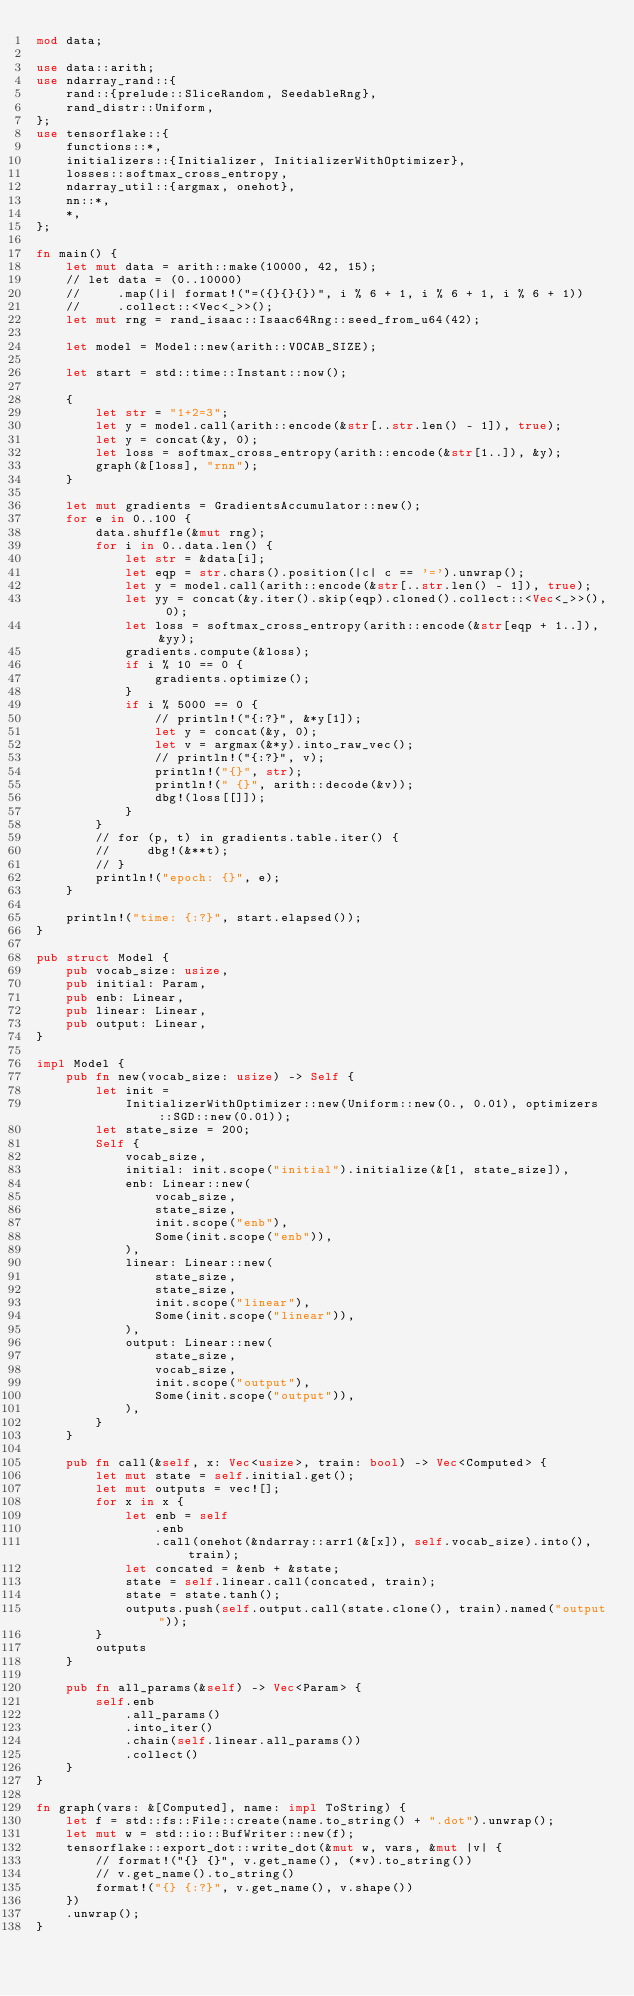<code> <loc_0><loc_0><loc_500><loc_500><_Rust_>mod data;

use data::arith;
use ndarray_rand::{
    rand::{prelude::SliceRandom, SeedableRng},
    rand_distr::Uniform,
};
use tensorflake::{
    functions::*,
    initializers::{Initializer, InitializerWithOptimizer},
    losses::softmax_cross_entropy,
    ndarray_util::{argmax, onehot},
    nn::*,
    *,
};

fn main() {
    let mut data = arith::make(10000, 42, 15);
    // let data = (0..10000)
    //     .map(|i| format!("=({}{}{})", i % 6 + 1, i % 6 + 1, i % 6 + 1))
    //     .collect::<Vec<_>>();
    let mut rng = rand_isaac::Isaac64Rng::seed_from_u64(42);

    let model = Model::new(arith::VOCAB_SIZE);

    let start = std::time::Instant::now();

    {
        let str = "1+2=3";
        let y = model.call(arith::encode(&str[..str.len() - 1]), true);
        let y = concat(&y, 0);
        let loss = softmax_cross_entropy(arith::encode(&str[1..]), &y);
        graph(&[loss], "rnn");
    }

    let mut gradients = GradientsAccumulator::new();
    for e in 0..100 {
        data.shuffle(&mut rng);
        for i in 0..data.len() {
            let str = &data[i];
            let eqp = str.chars().position(|c| c == '=').unwrap();
            let y = model.call(arith::encode(&str[..str.len() - 1]), true);
            let yy = concat(&y.iter().skip(eqp).cloned().collect::<Vec<_>>(), 0);
            let loss = softmax_cross_entropy(arith::encode(&str[eqp + 1..]), &yy);
            gradients.compute(&loss);
            if i % 10 == 0 {
                gradients.optimize();
            }
            if i % 5000 == 0 {
                // println!("{:?}", &*y[1]);
                let y = concat(&y, 0);
                let v = argmax(&*y).into_raw_vec();
                // println!("{:?}", v);
                println!("{}", str);
                println!(" {}", arith::decode(&v));
                dbg!(loss[[]]);
            }
        }
        // for (p, t) in gradients.table.iter() {
        //     dbg!(&**t);
        // }
        println!("epoch: {}", e);
    }

    println!("time: {:?}", start.elapsed());
}

pub struct Model {
    pub vocab_size: usize,
    pub initial: Param,
    pub enb: Linear,
    pub linear: Linear,
    pub output: Linear,
}

impl Model {
    pub fn new(vocab_size: usize) -> Self {
        let init =
            InitializerWithOptimizer::new(Uniform::new(0., 0.01), optimizers::SGD::new(0.01));
        let state_size = 200;
        Self {
            vocab_size,
            initial: init.scope("initial").initialize(&[1, state_size]),
            enb: Linear::new(
                vocab_size,
                state_size,
                init.scope("enb"),
                Some(init.scope("enb")),
            ),
            linear: Linear::new(
                state_size,
                state_size,
                init.scope("linear"),
                Some(init.scope("linear")),
            ),
            output: Linear::new(
                state_size,
                vocab_size,
                init.scope("output"),
                Some(init.scope("output")),
            ),
        }
    }

    pub fn call(&self, x: Vec<usize>, train: bool) -> Vec<Computed> {
        let mut state = self.initial.get();
        let mut outputs = vec![];
        for x in x {
            let enb = self
                .enb
                .call(onehot(&ndarray::arr1(&[x]), self.vocab_size).into(), train);
            let concated = &enb + &state;
            state = self.linear.call(concated, train);
            state = state.tanh();
            outputs.push(self.output.call(state.clone(), train).named("output"));
        }
        outputs
    }

    pub fn all_params(&self) -> Vec<Param> {
        self.enb
            .all_params()
            .into_iter()
            .chain(self.linear.all_params())
            .collect()
    }
}

fn graph(vars: &[Computed], name: impl ToString) {
    let f = std::fs::File::create(name.to_string() + ".dot").unwrap();
    let mut w = std::io::BufWriter::new(f);
    tensorflake::export_dot::write_dot(&mut w, vars, &mut |v| {
        // format!("{} {}", v.get_name(), (*v).to_string())
        // v.get_name().to_string()
        format!("{} {:?}", v.get_name(), v.shape())
    })
    .unwrap();
}
</code> 